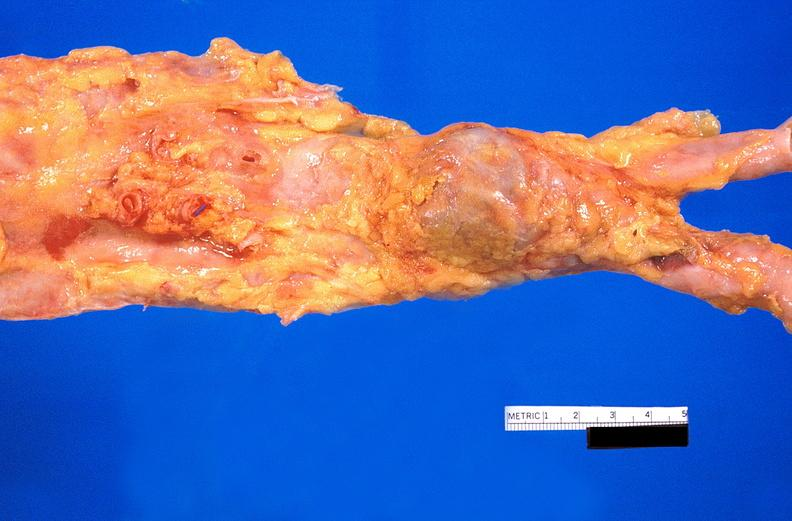does lateral view show abdominal aorta, atherosclerosis and fusiform aneurysm?
Answer the question using a single word or phrase. No 